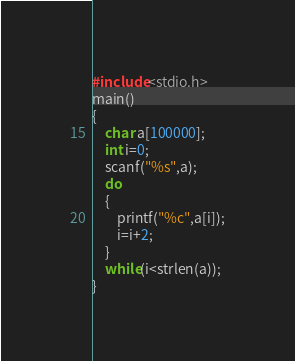<code> <loc_0><loc_0><loc_500><loc_500><_C_>#include<stdio.h>
main()
{
    char a[100000];
    int i=0;
    scanf("%s",a);
    do
    {
        printf("%c",a[i]);
        i=i+2;
    }
    while(i<strlen(a));
}

</code> 